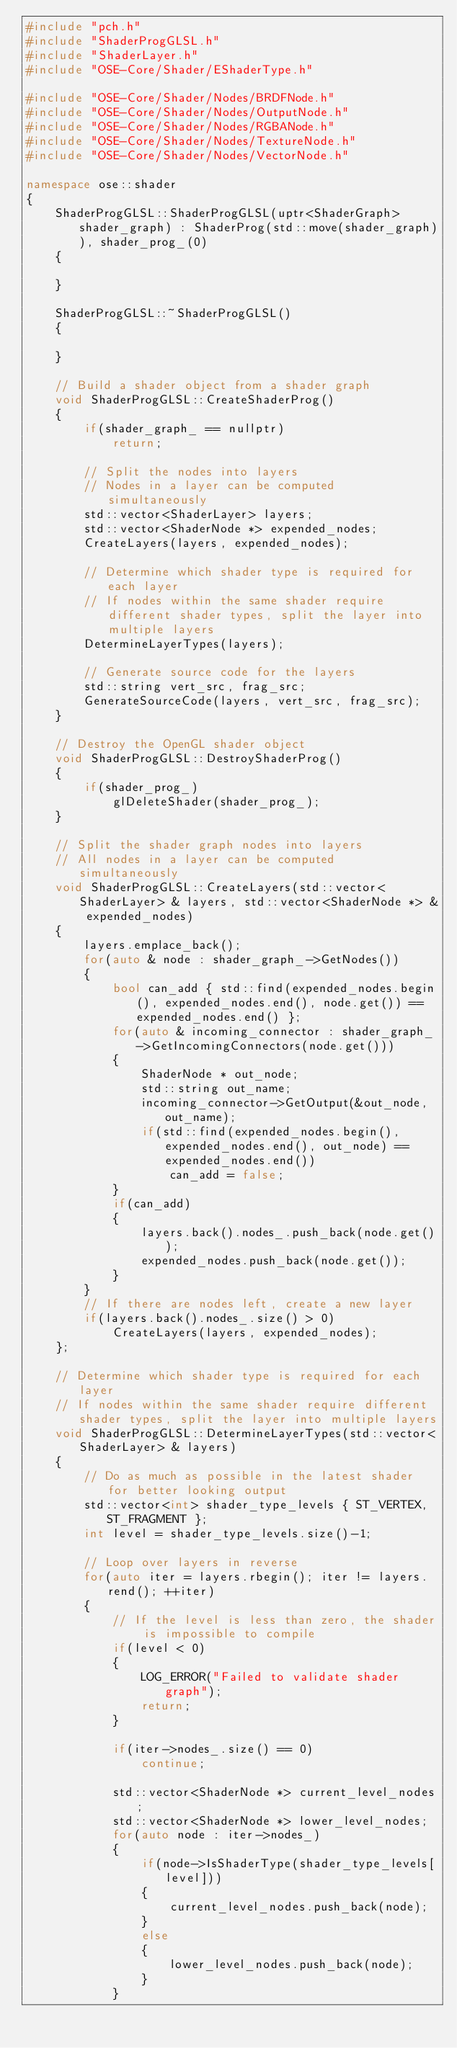Convert code to text. <code><loc_0><loc_0><loc_500><loc_500><_C++_>#include "pch.h"
#include "ShaderProgGLSL.h"
#include "ShaderLayer.h"
#include "OSE-Core/Shader/EShaderType.h"

#include "OSE-Core/Shader/Nodes/BRDFNode.h"
#include "OSE-Core/Shader/Nodes/OutputNode.h"
#include "OSE-Core/Shader/Nodes/RGBANode.h"
#include "OSE-Core/Shader/Nodes/TextureNode.h"
#include "OSE-Core/Shader/Nodes/VectorNode.h"

namespace ose::shader
{
	ShaderProgGLSL::ShaderProgGLSL(uptr<ShaderGraph> shader_graph) : ShaderProg(std::move(shader_graph)), shader_prog_(0)
	{

	}

	ShaderProgGLSL::~ShaderProgGLSL()
	{

	}

	// Build a shader object from a shader graph
	void ShaderProgGLSL::CreateShaderProg()
	{
		if(shader_graph_ == nullptr)
			return;

		// Split the nodes into layers
		// Nodes in a layer can be computed simultaneously
		std::vector<ShaderLayer> layers;
		std::vector<ShaderNode *> expended_nodes;
		CreateLayers(layers, expended_nodes);

		// Determine which shader type is required for each layer
		// If nodes within the same shader require different shader types, split the layer into multiple layers
		DetermineLayerTypes(layers);

		// Generate source code for the layers
		std::string vert_src, frag_src;
		GenerateSourceCode(layers, vert_src, frag_src);
	}

	// Destroy the OpenGL shader object
	void ShaderProgGLSL::DestroyShaderProg()
	{
		if(shader_prog_)
			glDeleteShader(shader_prog_);
	}

	// Split the shader graph nodes into layers
	// All nodes in a layer can be computed simultaneously
	void ShaderProgGLSL::CreateLayers(std::vector<ShaderLayer> & layers, std::vector<ShaderNode *> & expended_nodes)
	{
		layers.emplace_back();
		for(auto & node : shader_graph_->GetNodes())
		{
			bool can_add { std::find(expended_nodes.begin(), expended_nodes.end(), node.get()) == expended_nodes.end() };
			for(auto & incoming_connector : shader_graph_->GetIncomingConnectors(node.get()))
			{
				ShaderNode * out_node;
				std::string out_name;
				incoming_connector->GetOutput(&out_node, out_name);
				if(std::find(expended_nodes.begin(), expended_nodes.end(), out_node) == expended_nodes.end())
					can_add = false;
			}
			if(can_add)
			{
				layers.back().nodes_.push_back(node.get());
				expended_nodes.push_back(node.get());
			}
		}
		// If there are nodes left, create a new layer
		if(layers.back().nodes_.size() > 0)
			CreateLayers(layers, expended_nodes);
	};

	// Determine which shader type is required for each layer
	// If nodes within the same shader require different shader types, split the layer into multiple layers
	void ShaderProgGLSL::DetermineLayerTypes(std::vector<ShaderLayer> & layers)
	{
		// Do as much as possible in the latest shader for better looking output
		std::vector<int> shader_type_levels { ST_VERTEX, ST_FRAGMENT };
		int level = shader_type_levels.size()-1;

		// Loop over layers in reverse
		for(auto iter = layers.rbegin(); iter != layers.rend(); ++iter)
		{
			// If the level is less than zero, the shader is impossible to compile
			if(level < 0)
			{
				LOG_ERROR("Failed to validate shader graph");
				return;
			}

			if(iter->nodes_.size() == 0)
				continue;

			std::vector<ShaderNode *> current_level_nodes;
			std::vector<ShaderNode *> lower_level_nodes;
			for(auto node : iter->nodes_)
			{
				if(node->IsShaderType(shader_type_levels[level]))
				{
					current_level_nodes.push_back(node);
				}
				else
				{
					lower_level_nodes.push_back(node);
				}
			}
</code> 